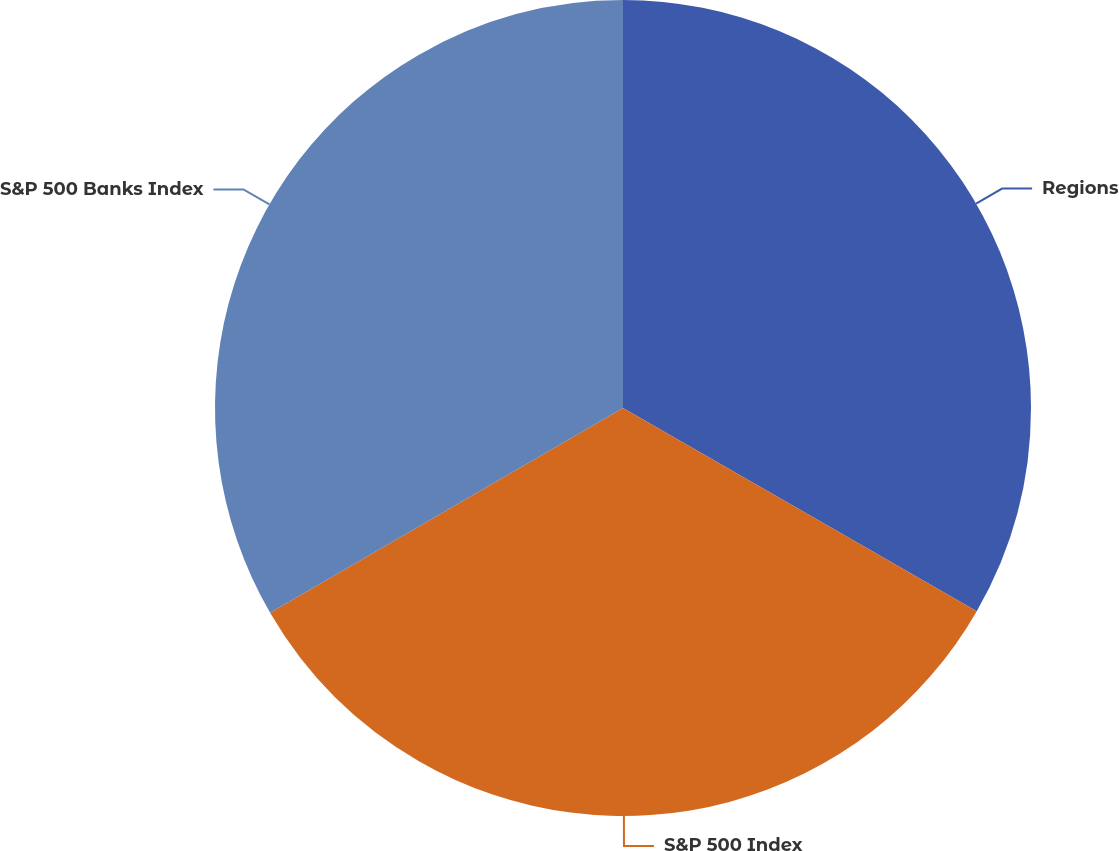Convert chart to OTSL. <chart><loc_0><loc_0><loc_500><loc_500><pie_chart><fcel>Regions<fcel>S&P 500 Index<fcel>S&P 500 Banks Index<nl><fcel>33.3%<fcel>33.33%<fcel>33.37%<nl></chart> 